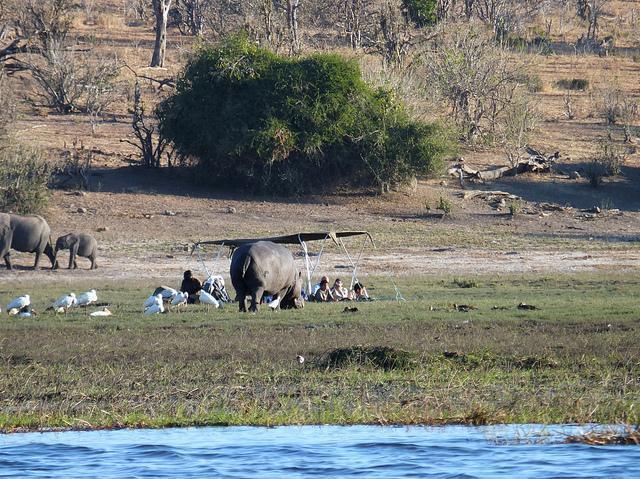How many elephants are there?
Give a very brief answer. 2. How many people are wearing an orange shirt?
Give a very brief answer. 0. 